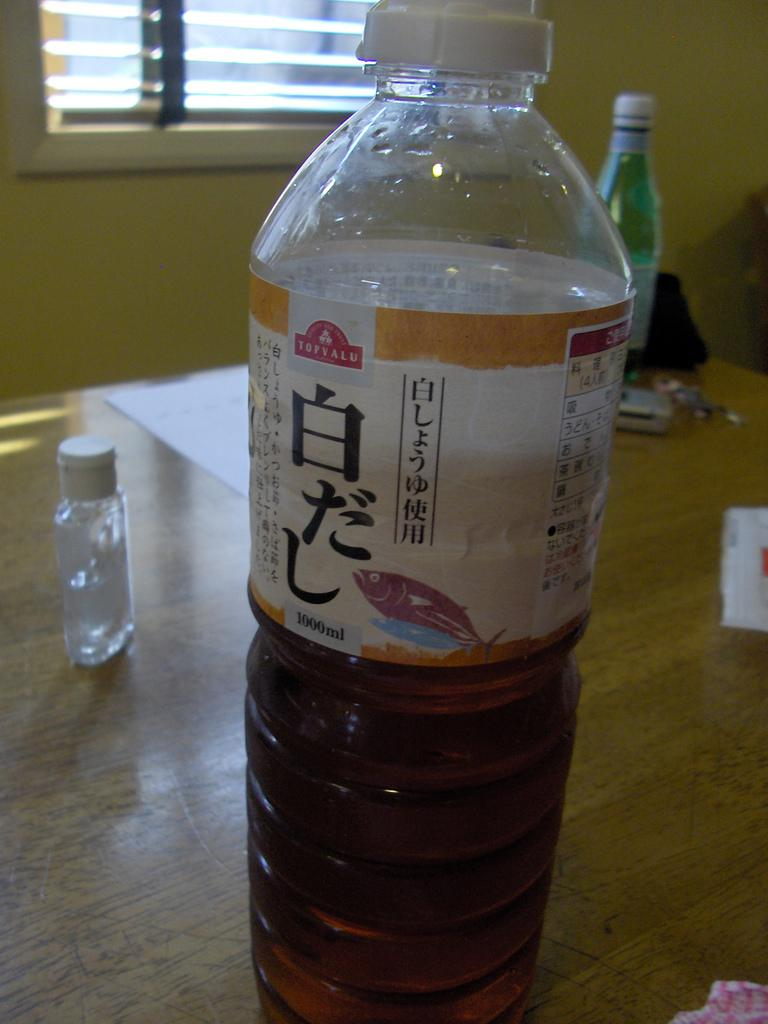Provide a one-sentence caption for the provided image. A clear bottle half filled with brown liquid with a Topvalu logo on it sits on a wooden table. 